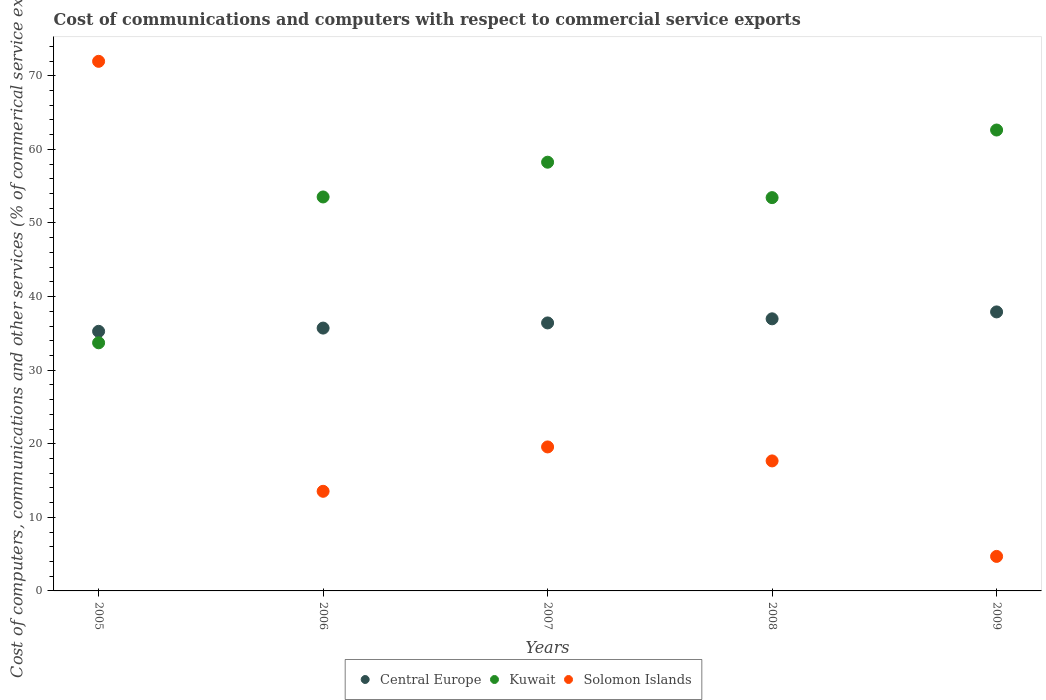What is the cost of communications and computers in Kuwait in 2008?
Provide a succinct answer. 53.44. Across all years, what is the maximum cost of communications and computers in Kuwait?
Provide a short and direct response. 62.63. Across all years, what is the minimum cost of communications and computers in Central Europe?
Keep it short and to the point. 35.28. In which year was the cost of communications and computers in Kuwait maximum?
Your answer should be very brief. 2009. In which year was the cost of communications and computers in Solomon Islands minimum?
Keep it short and to the point. 2009. What is the total cost of communications and computers in Solomon Islands in the graph?
Provide a short and direct response. 127.43. What is the difference between the cost of communications and computers in Central Europe in 2007 and that in 2009?
Offer a very short reply. -1.5. What is the difference between the cost of communications and computers in Central Europe in 2006 and the cost of communications and computers in Solomon Islands in 2008?
Your answer should be compact. 18.05. What is the average cost of communications and computers in Kuwait per year?
Your answer should be compact. 52.32. In the year 2007, what is the difference between the cost of communications and computers in Solomon Islands and cost of communications and computers in Kuwait?
Your answer should be very brief. -38.69. In how many years, is the cost of communications and computers in Solomon Islands greater than 34 %?
Provide a succinct answer. 1. What is the ratio of the cost of communications and computers in Central Europe in 2005 to that in 2007?
Ensure brevity in your answer.  0.97. Is the cost of communications and computers in Central Europe in 2007 less than that in 2009?
Ensure brevity in your answer.  Yes. Is the difference between the cost of communications and computers in Solomon Islands in 2005 and 2008 greater than the difference between the cost of communications and computers in Kuwait in 2005 and 2008?
Ensure brevity in your answer.  Yes. What is the difference between the highest and the second highest cost of communications and computers in Kuwait?
Offer a very short reply. 4.37. What is the difference between the highest and the lowest cost of communications and computers in Central Europe?
Make the answer very short. 2.64. Is it the case that in every year, the sum of the cost of communications and computers in Solomon Islands and cost of communications and computers in Kuwait  is greater than the cost of communications and computers in Central Europe?
Provide a short and direct response. Yes. Is the cost of communications and computers in Central Europe strictly greater than the cost of communications and computers in Kuwait over the years?
Offer a terse response. No. Is the cost of communications and computers in Kuwait strictly less than the cost of communications and computers in Central Europe over the years?
Provide a succinct answer. No. How many dotlines are there?
Make the answer very short. 3. What is the difference between two consecutive major ticks on the Y-axis?
Your response must be concise. 10. Are the values on the major ticks of Y-axis written in scientific E-notation?
Your answer should be very brief. No. Does the graph contain any zero values?
Your answer should be very brief. No. How many legend labels are there?
Your answer should be compact. 3. What is the title of the graph?
Provide a succinct answer. Cost of communications and computers with respect to commercial service exports. What is the label or title of the X-axis?
Your answer should be very brief. Years. What is the label or title of the Y-axis?
Offer a very short reply. Cost of computers, communications and other services (% of commerical service exports). What is the Cost of computers, communications and other services (% of commerical service exports) of Central Europe in 2005?
Provide a succinct answer. 35.28. What is the Cost of computers, communications and other services (% of commerical service exports) in Kuwait in 2005?
Give a very brief answer. 33.72. What is the Cost of computers, communications and other services (% of commerical service exports) of Solomon Islands in 2005?
Offer a very short reply. 71.97. What is the Cost of computers, communications and other services (% of commerical service exports) in Central Europe in 2006?
Your answer should be very brief. 35.72. What is the Cost of computers, communications and other services (% of commerical service exports) in Kuwait in 2006?
Ensure brevity in your answer.  53.54. What is the Cost of computers, communications and other services (% of commerical service exports) in Solomon Islands in 2006?
Offer a terse response. 13.54. What is the Cost of computers, communications and other services (% of commerical service exports) of Central Europe in 2007?
Give a very brief answer. 36.42. What is the Cost of computers, communications and other services (% of commerical service exports) of Kuwait in 2007?
Your answer should be compact. 58.26. What is the Cost of computers, communications and other services (% of commerical service exports) of Solomon Islands in 2007?
Keep it short and to the point. 19.57. What is the Cost of computers, communications and other services (% of commerical service exports) in Central Europe in 2008?
Your answer should be very brief. 36.98. What is the Cost of computers, communications and other services (% of commerical service exports) in Kuwait in 2008?
Provide a short and direct response. 53.44. What is the Cost of computers, communications and other services (% of commerical service exports) of Solomon Islands in 2008?
Ensure brevity in your answer.  17.67. What is the Cost of computers, communications and other services (% of commerical service exports) in Central Europe in 2009?
Your response must be concise. 37.91. What is the Cost of computers, communications and other services (% of commerical service exports) in Kuwait in 2009?
Offer a terse response. 62.63. What is the Cost of computers, communications and other services (% of commerical service exports) in Solomon Islands in 2009?
Ensure brevity in your answer.  4.69. Across all years, what is the maximum Cost of computers, communications and other services (% of commerical service exports) of Central Europe?
Offer a very short reply. 37.91. Across all years, what is the maximum Cost of computers, communications and other services (% of commerical service exports) in Kuwait?
Your response must be concise. 62.63. Across all years, what is the maximum Cost of computers, communications and other services (% of commerical service exports) of Solomon Islands?
Give a very brief answer. 71.97. Across all years, what is the minimum Cost of computers, communications and other services (% of commerical service exports) of Central Europe?
Make the answer very short. 35.28. Across all years, what is the minimum Cost of computers, communications and other services (% of commerical service exports) of Kuwait?
Offer a terse response. 33.72. Across all years, what is the minimum Cost of computers, communications and other services (% of commerical service exports) of Solomon Islands?
Ensure brevity in your answer.  4.69. What is the total Cost of computers, communications and other services (% of commerical service exports) in Central Europe in the graph?
Offer a terse response. 182.3. What is the total Cost of computers, communications and other services (% of commerical service exports) of Kuwait in the graph?
Your response must be concise. 261.59. What is the total Cost of computers, communications and other services (% of commerical service exports) of Solomon Islands in the graph?
Offer a very short reply. 127.43. What is the difference between the Cost of computers, communications and other services (% of commerical service exports) in Central Europe in 2005 and that in 2006?
Your answer should be compact. -0.44. What is the difference between the Cost of computers, communications and other services (% of commerical service exports) of Kuwait in 2005 and that in 2006?
Your response must be concise. -19.82. What is the difference between the Cost of computers, communications and other services (% of commerical service exports) in Solomon Islands in 2005 and that in 2006?
Keep it short and to the point. 58.43. What is the difference between the Cost of computers, communications and other services (% of commerical service exports) in Central Europe in 2005 and that in 2007?
Your response must be concise. -1.14. What is the difference between the Cost of computers, communications and other services (% of commerical service exports) of Kuwait in 2005 and that in 2007?
Provide a short and direct response. -24.54. What is the difference between the Cost of computers, communications and other services (% of commerical service exports) in Solomon Islands in 2005 and that in 2007?
Your answer should be compact. 52.4. What is the difference between the Cost of computers, communications and other services (% of commerical service exports) in Central Europe in 2005 and that in 2008?
Keep it short and to the point. -1.7. What is the difference between the Cost of computers, communications and other services (% of commerical service exports) in Kuwait in 2005 and that in 2008?
Your answer should be compact. -19.73. What is the difference between the Cost of computers, communications and other services (% of commerical service exports) of Solomon Islands in 2005 and that in 2008?
Give a very brief answer. 54.3. What is the difference between the Cost of computers, communications and other services (% of commerical service exports) in Central Europe in 2005 and that in 2009?
Give a very brief answer. -2.64. What is the difference between the Cost of computers, communications and other services (% of commerical service exports) in Kuwait in 2005 and that in 2009?
Offer a very short reply. -28.92. What is the difference between the Cost of computers, communications and other services (% of commerical service exports) in Solomon Islands in 2005 and that in 2009?
Keep it short and to the point. 67.28. What is the difference between the Cost of computers, communications and other services (% of commerical service exports) of Central Europe in 2006 and that in 2007?
Your response must be concise. -0.7. What is the difference between the Cost of computers, communications and other services (% of commerical service exports) in Kuwait in 2006 and that in 2007?
Offer a very short reply. -4.72. What is the difference between the Cost of computers, communications and other services (% of commerical service exports) of Solomon Islands in 2006 and that in 2007?
Provide a short and direct response. -6.03. What is the difference between the Cost of computers, communications and other services (% of commerical service exports) of Central Europe in 2006 and that in 2008?
Offer a terse response. -1.26. What is the difference between the Cost of computers, communications and other services (% of commerical service exports) in Kuwait in 2006 and that in 2008?
Your answer should be compact. 0.09. What is the difference between the Cost of computers, communications and other services (% of commerical service exports) of Solomon Islands in 2006 and that in 2008?
Your response must be concise. -4.13. What is the difference between the Cost of computers, communications and other services (% of commerical service exports) in Central Europe in 2006 and that in 2009?
Your answer should be compact. -2.2. What is the difference between the Cost of computers, communications and other services (% of commerical service exports) in Kuwait in 2006 and that in 2009?
Keep it short and to the point. -9.1. What is the difference between the Cost of computers, communications and other services (% of commerical service exports) in Solomon Islands in 2006 and that in 2009?
Your answer should be very brief. 8.85. What is the difference between the Cost of computers, communications and other services (% of commerical service exports) of Central Europe in 2007 and that in 2008?
Your answer should be very brief. -0.56. What is the difference between the Cost of computers, communications and other services (% of commerical service exports) in Kuwait in 2007 and that in 2008?
Offer a terse response. 4.81. What is the difference between the Cost of computers, communications and other services (% of commerical service exports) of Solomon Islands in 2007 and that in 2008?
Give a very brief answer. 1.9. What is the difference between the Cost of computers, communications and other services (% of commerical service exports) of Central Europe in 2007 and that in 2009?
Offer a terse response. -1.5. What is the difference between the Cost of computers, communications and other services (% of commerical service exports) of Kuwait in 2007 and that in 2009?
Offer a terse response. -4.37. What is the difference between the Cost of computers, communications and other services (% of commerical service exports) of Solomon Islands in 2007 and that in 2009?
Offer a very short reply. 14.88. What is the difference between the Cost of computers, communications and other services (% of commerical service exports) in Central Europe in 2008 and that in 2009?
Keep it short and to the point. -0.94. What is the difference between the Cost of computers, communications and other services (% of commerical service exports) of Kuwait in 2008 and that in 2009?
Your answer should be very brief. -9.19. What is the difference between the Cost of computers, communications and other services (% of commerical service exports) in Solomon Islands in 2008 and that in 2009?
Provide a short and direct response. 12.98. What is the difference between the Cost of computers, communications and other services (% of commerical service exports) of Central Europe in 2005 and the Cost of computers, communications and other services (% of commerical service exports) of Kuwait in 2006?
Offer a terse response. -18.26. What is the difference between the Cost of computers, communications and other services (% of commerical service exports) in Central Europe in 2005 and the Cost of computers, communications and other services (% of commerical service exports) in Solomon Islands in 2006?
Offer a terse response. 21.74. What is the difference between the Cost of computers, communications and other services (% of commerical service exports) of Kuwait in 2005 and the Cost of computers, communications and other services (% of commerical service exports) of Solomon Islands in 2006?
Provide a short and direct response. 20.18. What is the difference between the Cost of computers, communications and other services (% of commerical service exports) in Central Europe in 2005 and the Cost of computers, communications and other services (% of commerical service exports) in Kuwait in 2007?
Your answer should be compact. -22.98. What is the difference between the Cost of computers, communications and other services (% of commerical service exports) in Central Europe in 2005 and the Cost of computers, communications and other services (% of commerical service exports) in Solomon Islands in 2007?
Provide a short and direct response. 15.71. What is the difference between the Cost of computers, communications and other services (% of commerical service exports) of Kuwait in 2005 and the Cost of computers, communications and other services (% of commerical service exports) of Solomon Islands in 2007?
Ensure brevity in your answer.  14.15. What is the difference between the Cost of computers, communications and other services (% of commerical service exports) in Central Europe in 2005 and the Cost of computers, communications and other services (% of commerical service exports) in Kuwait in 2008?
Offer a terse response. -18.17. What is the difference between the Cost of computers, communications and other services (% of commerical service exports) in Central Europe in 2005 and the Cost of computers, communications and other services (% of commerical service exports) in Solomon Islands in 2008?
Offer a terse response. 17.61. What is the difference between the Cost of computers, communications and other services (% of commerical service exports) of Kuwait in 2005 and the Cost of computers, communications and other services (% of commerical service exports) of Solomon Islands in 2008?
Give a very brief answer. 16.05. What is the difference between the Cost of computers, communications and other services (% of commerical service exports) of Central Europe in 2005 and the Cost of computers, communications and other services (% of commerical service exports) of Kuwait in 2009?
Provide a succinct answer. -27.36. What is the difference between the Cost of computers, communications and other services (% of commerical service exports) in Central Europe in 2005 and the Cost of computers, communications and other services (% of commerical service exports) in Solomon Islands in 2009?
Offer a very short reply. 30.59. What is the difference between the Cost of computers, communications and other services (% of commerical service exports) of Kuwait in 2005 and the Cost of computers, communications and other services (% of commerical service exports) of Solomon Islands in 2009?
Your response must be concise. 29.03. What is the difference between the Cost of computers, communications and other services (% of commerical service exports) of Central Europe in 2006 and the Cost of computers, communications and other services (% of commerical service exports) of Kuwait in 2007?
Provide a short and direct response. -22.54. What is the difference between the Cost of computers, communications and other services (% of commerical service exports) of Central Europe in 2006 and the Cost of computers, communications and other services (% of commerical service exports) of Solomon Islands in 2007?
Ensure brevity in your answer.  16.15. What is the difference between the Cost of computers, communications and other services (% of commerical service exports) in Kuwait in 2006 and the Cost of computers, communications and other services (% of commerical service exports) in Solomon Islands in 2007?
Your response must be concise. 33.97. What is the difference between the Cost of computers, communications and other services (% of commerical service exports) in Central Europe in 2006 and the Cost of computers, communications and other services (% of commerical service exports) in Kuwait in 2008?
Keep it short and to the point. -17.73. What is the difference between the Cost of computers, communications and other services (% of commerical service exports) in Central Europe in 2006 and the Cost of computers, communications and other services (% of commerical service exports) in Solomon Islands in 2008?
Your answer should be compact. 18.05. What is the difference between the Cost of computers, communications and other services (% of commerical service exports) in Kuwait in 2006 and the Cost of computers, communications and other services (% of commerical service exports) in Solomon Islands in 2008?
Your answer should be very brief. 35.87. What is the difference between the Cost of computers, communications and other services (% of commerical service exports) in Central Europe in 2006 and the Cost of computers, communications and other services (% of commerical service exports) in Kuwait in 2009?
Offer a terse response. -26.92. What is the difference between the Cost of computers, communications and other services (% of commerical service exports) in Central Europe in 2006 and the Cost of computers, communications and other services (% of commerical service exports) in Solomon Islands in 2009?
Your response must be concise. 31.03. What is the difference between the Cost of computers, communications and other services (% of commerical service exports) in Kuwait in 2006 and the Cost of computers, communications and other services (% of commerical service exports) in Solomon Islands in 2009?
Provide a succinct answer. 48.85. What is the difference between the Cost of computers, communications and other services (% of commerical service exports) of Central Europe in 2007 and the Cost of computers, communications and other services (% of commerical service exports) of Kuwait in 2008?
Provide a short and direct response. -17.03. What is the difference between the Cost of computers, communications and other services (% of commerical service exports) of Central Europe in 2007 and the Cost of computers, communications and other services (% of commerical service exports) of Solomon Islands in 2008?
Your response must be concise. 18.75. What is the difference between the Cost of computers, communications and other services (% of commerical service exports) in Kuwait in 2007 and the Cost of computers, communications and other services (% of commerical service exports) in Solomon Islands in 2008?
Your answer should be very brief. 40.59. What is the difference between the Cost of computers, communications and other services (% of commerical service exports) in Central Europe in 2007 and the Cost of computers, communications and other services (% of commerical service exports) in Kuwait in 2009?
Offer a very short reply. -26.21. What is the difference between the Cost of computers, communications and other services (% of commerical service exports) of Central Europe in 2007 and the Cost of computers, communications and other services (% of commerical service exports) of Solomon Islands in 2009?
Offer a terse response. 31.73. What is the difference between the Cost of computers, communications and other services (% of commerical service exports) in Kuwait in 2007 and the Cost of computers, communications and other services (% of commerical service exports) in Solomon Islands in 2009?
Offer a very short reply. 53.57. What is the difference between the Cost of computers, communications and other services (% of commerical service exports) in Central Europe in 2008 and the Cost of computers, communications and other services (% of commerical service exports) in Kuwait in 2009?
Give a very brief answer. -25.66. What is the difference between the Cost of computers, communications and other services (% of commerical service exports) of Central Europe in 2008 and the Cost of computers, communications and other services (% of commerical service exports) of Solomon Islands in 2009?
Offer a very short reply. 32.29. What is the difference between the Cost of computers, communications and other services (% of commerical service exports) of Kuwait in 2008 and the Cost of computers, communications and other services (% of commerical service exports) of Solomon Islands in 2009?
Make the answer very short. 48.75. What is the average Cost of computers, communications and other services (% of commerical service exports) in Central Europe per year?
Offer a very short reply. 36.46. What is the average Cost of computers, communications and other services (% of commerical service exports) of Kuwait per year?
Your response must be concise. 52.32. What is the average Cost of computers, communications and other services (% of commerical service exports) of Solomon Islands per year?
Ensure brevity in your answer.  25.49. In the year 2005, what is the difference between the Cost of computers, communications and other services (% of commerical service exports) of Central Europe and Cost of computers, communications and other services (% of commerical service exports) of Kuwait?
Offer a terse response. 1.56. In the year 2005, what is the difference between the Cost of computers, communications and other services (% of commerical service exports) in Central Europe and Cost of computers, communications and other services (% of commerical service exports) in Solomon Islands?
Provide a succinct answer. -36.69. In the year 2005, what is the difference between the Cost of computers, communications and other services (% of commerical service exports) in Kuwait and Cost of computers, communications and other services (% of commerical service exports) in Solomon Islands?
Give a very brief answer. -38.25. In the year 2006, what is the difference between the Cost of computers, communications and other services (% of commerical service exports) in Central Europe and Cost of computers, communications and other services (% of commerical service exports) in Kuwait?
Offer a terse response. -17.82. In the year 2006, what is the difference between the Cost of computers, communications and other services (% of commerical service exports) in Central Europe and Cost of computers, communications and other services (% of commerical service exports) in Solomon Islands?
Offer a terse response. 22.18. In the year 2006, what is the difference between the Cost of computers, communications and other services (% of commerical service exports) of Kuwait and Cost of computers, communications and other services (% of commerical service exports) of Solomon Islands?
Ensure brevity in your answer.  40. In the year 2007, what is the difference between the Cost of computers, communications and other services (% of commerical service exports) in Central Europe and Cost of computers, communications and other services (% of commerical service exports) in Kuwait?
Offer a terse response. -21.84. In the year 2007, what is the difference between the Cost of computers, communications and other services (% of commerical service exports) of Central Europe and Cost of computers, communications and other services (% of commerical service exports) of Solomon Islands?
Offer a terse response. 16.85. In the year 2007, what is the difference between the Cost of computers, communications and other services (% of commerical service exports) of Kuwait and Cost of computers, communications and other services (% of commerical service exports) of Solomon Islands?
Provide a short and direct response. 38.69. In the year 2008, what is the difference between the Cost of computers, communications and other services (% of commerical service exports) in Central Europe and Cost of computers, communications and other services (% of commerical service exports) in Kuwait?
Your answer should be very brief. -16.47. In the year 2008, what is the difference between the Cost of computers, communications and other services (% of commerical service exports) in Central Europe and Cost of computers, communications and other services (% of commerical service exports) in Solomon Islands?
Ensure brevity in your answer.  19.31. In the year 2008, what is the difference between the Cost of computers, communications and other services (% of commerical service exports) of Kuwait and Cost of computers, communications and other services (% of commerical service exports) of Solomon Islands?
Provide a succinct answer. 35.78. In the year 2009, what is the difference between the Cost of computers, communications and other services (% of commerical service exports) in Central Europe and Cost of computers, communications and other services (% of commerical service exports) in Kuwait?
Your answer should be compact. -24.72. In the year 2009, what is the difference between the Cost of computers, communications and other services (% of commerical service exports) of Central Europe and Cost of computers, communications and other services (% of commerical service exports) of Solomon Islands?
Your answer should be compact. 33.22. In the year 2009, what is the difference between the Cost of computers, communications and other services (% of commerical service exports) in Kuwait and Cost of computers, communications and other services (% of commerical service exports) in Solomon Islands?
Your answer should be very brief. 57.94. What is the ratio of the Cost of computers, communications and other services (% of commerical service exports) in Central Europe in 2005 to that in 2006?
Your response must be concise. 0.99. What is the ratio of the Cost of computers, communications and other services (% of commerical service exports) of Kuwait in 2005 to that in 2006?
Offer a terse response. 0.63. What is the ratio of the Cost of computers, communications and other services (% of commerical service exports) in Solomon Islands in 2005 to that in 2006?
Provide a succinct answer. 5.32. What is the ratio of the Cost of computers, communications and other services (% of commerical service exports) in Central Europe in 2005 to that in 2007?
Offer a terse response. 0.97. What is the ratio of the Cost of computers, communications and other services (% of commerical service exports) of Kuwait in 2005 to that in 2007?
Offer a terse response. 0.58. What is the ratio of the Cost of computers, communications and other services (% of commerical service exports) in Solomon Islands in 2005 to that in 2007?
Provide a succinct answer. 3.68. What is the ratio of the Cost of computers, communications and other services (% of commerical service exports) of Central Europe in 2005 to that in 2008?
Your answer should be very brief. 0.95. What is the ratio of the Cost of computers, communications and other services (% of commerical service exports) of Kuwait in 2005 to that in 2008?
Keep it short and to the point. 0.63. What is the ratio of the Cost of computers, communications and other services (% of commerical service exports) of Solomon Islands in 2005 to that in 2008?
Your answer should be compact. 4.07. What is the ratio of the Cost of computers, communications and other services (% of commerical service exports) of Central Europe in 2005 to that in 2009?
Offer a very short reply. 0.93. What is the ratio of the Cost of computers, communications and other services (% of commerical service exports) in Kuwait in 2005 to that in 2009?
Keep it short and to the point. 0.54. What is the ratio of the Cost of computers, communications and other services (% of commerical service exports) of Solomon Islands in 2005 to that in 2009?
Offer a terse response. 15.34. What is the ratio of the Cost of computers, communications and other services (% of commerical service exports) of Central Europe in 2006 to that in 2007?
Ensure brevity in your answer.  0.98. What is the ratio of the Cost of computers, communications and other services (% of commerical service exports) in Kuwait in 2006 to that in 2007?
Ensure brevity in your answer.  0.92. What is the ratio of the Cost of computers, communications and other services (% of commerical service exports) in Solomon Islands in 2006 to that in 2007?
Your answer should be very brief. 0.69. What is the ratio of the Cost of computers, communications and other services (% of commerical service exports) in Central Europe in 2006 to that in 2008?
Ensure brevity in your answer.  0.97. What is the ratio of the Cost of computers, communications and other services (% of commerical service exports) of Kuwait in 2006 to that in 2008?
Ensure brevity in your answer.  1. What is the ratio of the Cost of computers, communications and other services (% of commerical service exports) in Solomon Islands in 2006 to that in 2008?
Offer a very short reply. 0.77. What is the ratio of the Cost of computers, communications and other services (% of commerical service exports) in Central Europe in 2006 to that in 2009?
Your answer should be very brief. 0.94. What is the ratio of the Cost of computers, communications and other services (% of commerical service exports) in Kuwait in 2006 to that in 2009?
Provide a short and direct response. 0.85. What is the ratio of the Cost of computers, communications and other services (% of commerical service exports) of Solomon Islands in 2006 to that in 2009?
Keep it short and to the point. 2.89. What is the ratio of the Cost of computers, communications and other services (% of commerical service exports) in Central Europe in 2007 to that in 2008?
Your answer should be very brief. 0.98. What is the ratio of the Cost of computers, communications and other services (% of commerical service exports) of Kuwait in 2007 to that in 2008?
Offer a very short reply. 1.09. What is the ratio of the Cost of computers, communications and other services (% of commerical service exports) in Solomon Islands in 2007 to that in 2008?
Your response must be concise. 1.11. What is the ratio of the Cost of computers, communications and other services (% of commerical service exports) in Central Europe in 2007 to that in 2009?
Provide a succinct answer. 0.96. What is the ratio of the Cost of computers, communications and other services (% of commerical service exports) in Kuwait in 2007 to that in 2009?
Give a very brief answer. 0.93. What is the ratio of the Cost of computers, communications and other services (% of commerical service exports) in Solomon Islands in 2007 to that in 2009?
Give a very brief answer. 4.17. What is the ratio of the Cost of computers, communications and other services (% of commerical service exports) in Central Europe in 2008 to that in 2009?
Provide a short and direct response. 0.98. What is the ratio of the Cost of computers, communications and other services (% of commerical service exports) of Kuwait in 2008 to that in 2009?
Keep it short and to the point. 0.85. What is the ratio of the Cost of computers, communications and other services (% of commerical service exports) in Solomon Islands in 2008 to that in 2009?
Keep it short and to the point. 3.77. What is the difference between the highest and the second highest Cost of computers, communications and other services (% of commerical service exports) of Central Europe?
Ensure brevity in your answer.  0.94. What is the difference between the highest and the second highest Cost of computers, communications and other services (% of commerical service exports) of Kuwait?
Provide a short and direct response. 4.37. What is the difference between the highest and the second highest Cost of computers, communications and other services (% of commerical service exports) in Solomon Islands?
Ensure brevity in your answer.  52.4. What is the difference between the highest and the lowest Cost of computers, communications and other services (% of commerical service exports) in Central Europe?
Your answer should be compact. 2.64. What is the difference between the highest and the lowest Cost of computers, communications and other services (% of commerical service exports) in Kuwait?
Your answer should be compact. 28.92. What is the difference between the highest and the lowest Cost of computers, communications and other services (% of commerical service exports) of Solomon Islands?
Ensure brevity in your answer.  67.28. 